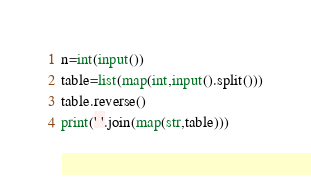<code> <loc_0><loc_0><loc_500><loc_500><_Python_>n=int(input())
table=list(map(int,input().split()))
table.reverse()
print(' '.join(map(str,table)))
</code> 